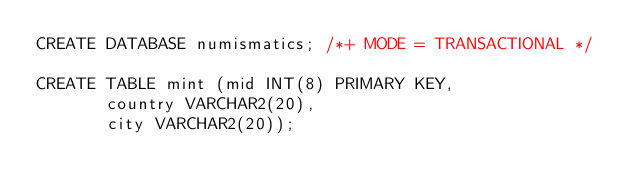Convert code to text. <code><loc_0><loc_0><loc_500><loc_500><_SQL_>CREATE DATABASE numismatics; /*+ MODE = TRANSACTIONAL */ 

CREATE TABLE mint (mid INT(8) PRIMARY KEY,
       country VARCHAR2(20),
       city VARCHAR2(20));   </code> 